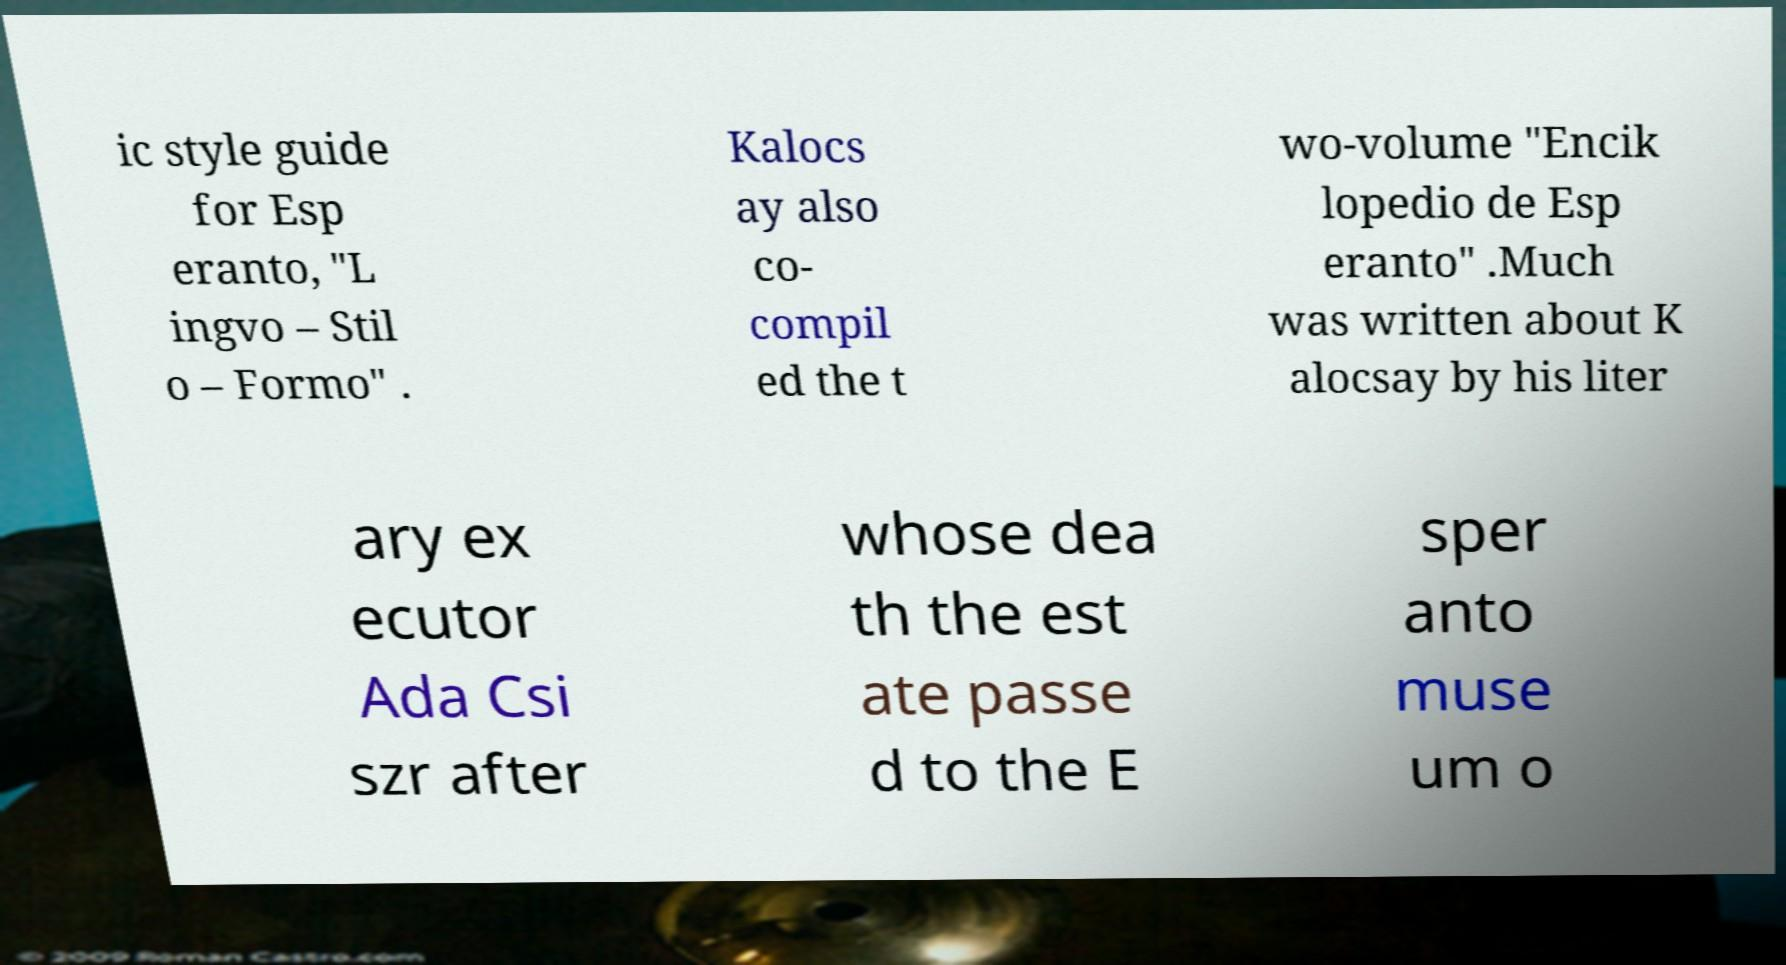Please read and relay the text visible in this image. What does it say? ic style guide for Esp eranto, "L ingvo – Stil o – Formo" . Kalocs ay also co- compil ed the t wo-volume "Encik lopedio de Esp eranto" .Much was written about K alocsay by his liter ary ex ecutor Ada Csi szr after whose dea th the est ate passe d to the E sper anto muse um o 